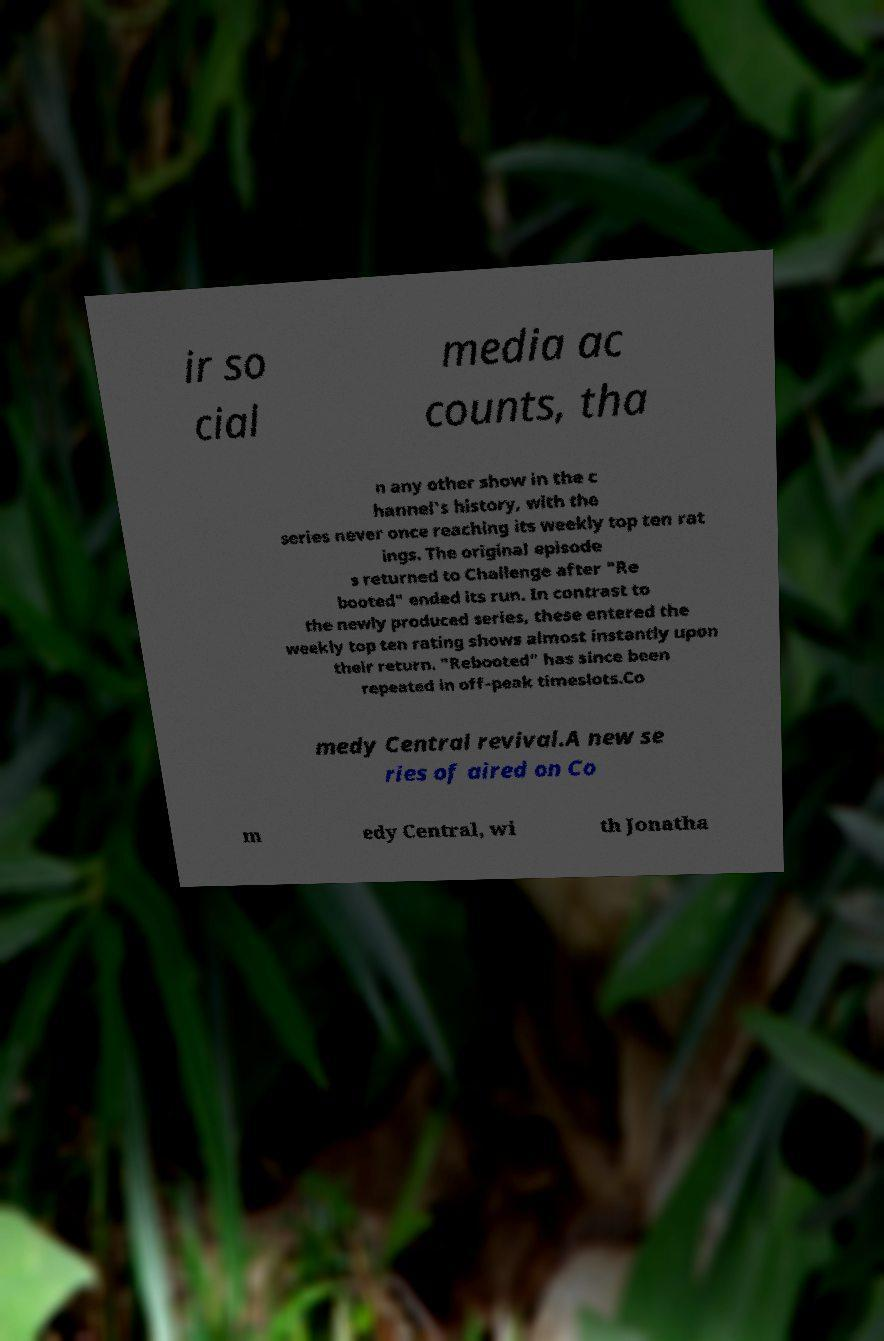There's text embedded in this image that I need extracted. Can you transcribe it verbatim? ir so cial media ac counts, tha n any other show in the c hannel's history, with the series never once reaching its weekly top ten rat ings. The original episode s returned to Challenge after "Re booted" ended its run. In contrast to the newly produced series, these entered the weekly top ten rating shows almost instantly upon their return. "Rebooted" has since been repeated in off-peak timeslots.Co medy Central revival.A new se ries of aired on Co m edy Central, wi th Jonatha 